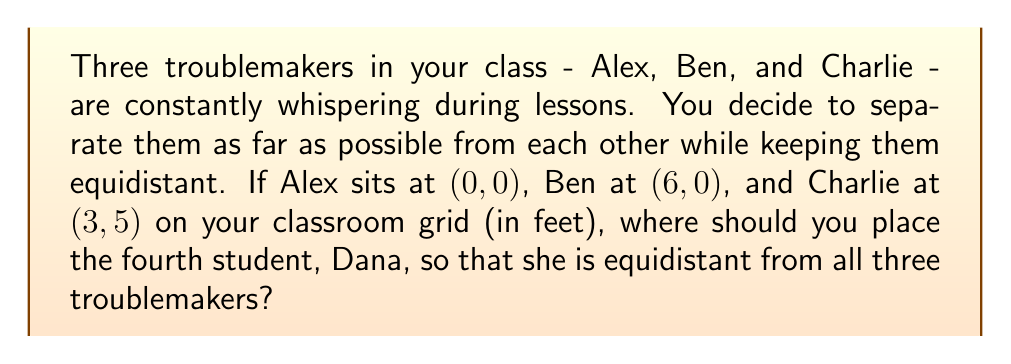Help me with this question. Let's approach this step-by-step:

1) The point equidistant from three given points is the center of the circle that passes through all three points. This center is located at the intersection of the perpendicular bisectors of any two sides of the triangle formed by the three points.

2) Let's find the midpoint of side AB (between Alex and Ben):
   $$(x_1, y_1) = (\frac{0+6}{2}, \frac{0+0}{2}) = (3, 0)$$

3) The slope of AB is 0, so the perpendicular bisector will have an undefined slope (vertical line):
   $$x = 3$$

4) Now, let's find the midpoint of AC (between Alex and Charlie):
   $$(x_2, y_2) = (\frac{0+3}{2}, \frac{0+5}{2}) = (1.5, 2.5)$$

5) The slope of AC is:
   $$m_{AC} = \frac{5-0}{3-0} = \frac{5}{3}$$

6) The perpendicular slope will be the negative reciprocal:
   $$m_{\perp AC} = -\frac{3}{5}$$

7) Using point-slope form with $(x_2, y_2)$:
   $$y - 2.5 = -\frac{3}{5}(x - 1.5)$$

8) Simplify to slope-intercept form:
   $$y = -\frac{3}{5}x + 3.4$$

9) The intersection of this line with the vertical line $x = 3$ will give us Dana's position:
   $$3 = -\frac{3}{5}(3) + 3.4$$
   $$y = 1.6$$

Therefore, Dana should be placed at (3, 1.6) on your classroom grid.
Answer: (3, 1.6) 